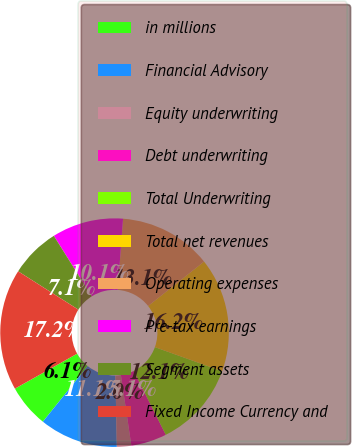<chart> <loc_0><loc_0><loc_500><loc_500><pie_chart><fcel>in millions<fcel>Financial Advisory<fcel>Equity underwriting<fcel>Debt underwriting<fcel>Total Underwriting<fcel>Total net revenues<fcel>Operating expenses<fcel>Pre-tax earnings<fcel>Segment assets<fcel>Fixed Income Currency and<nl><fcel>6.06%<fcel>11.11%<fcel>2.03%<fcel>5.05%<fcel>12.12%<fcel>16.16%<fcel>13.13%<fcel>10.1%<fcel>7.07%<fcel>17.17%<nl></chart> 